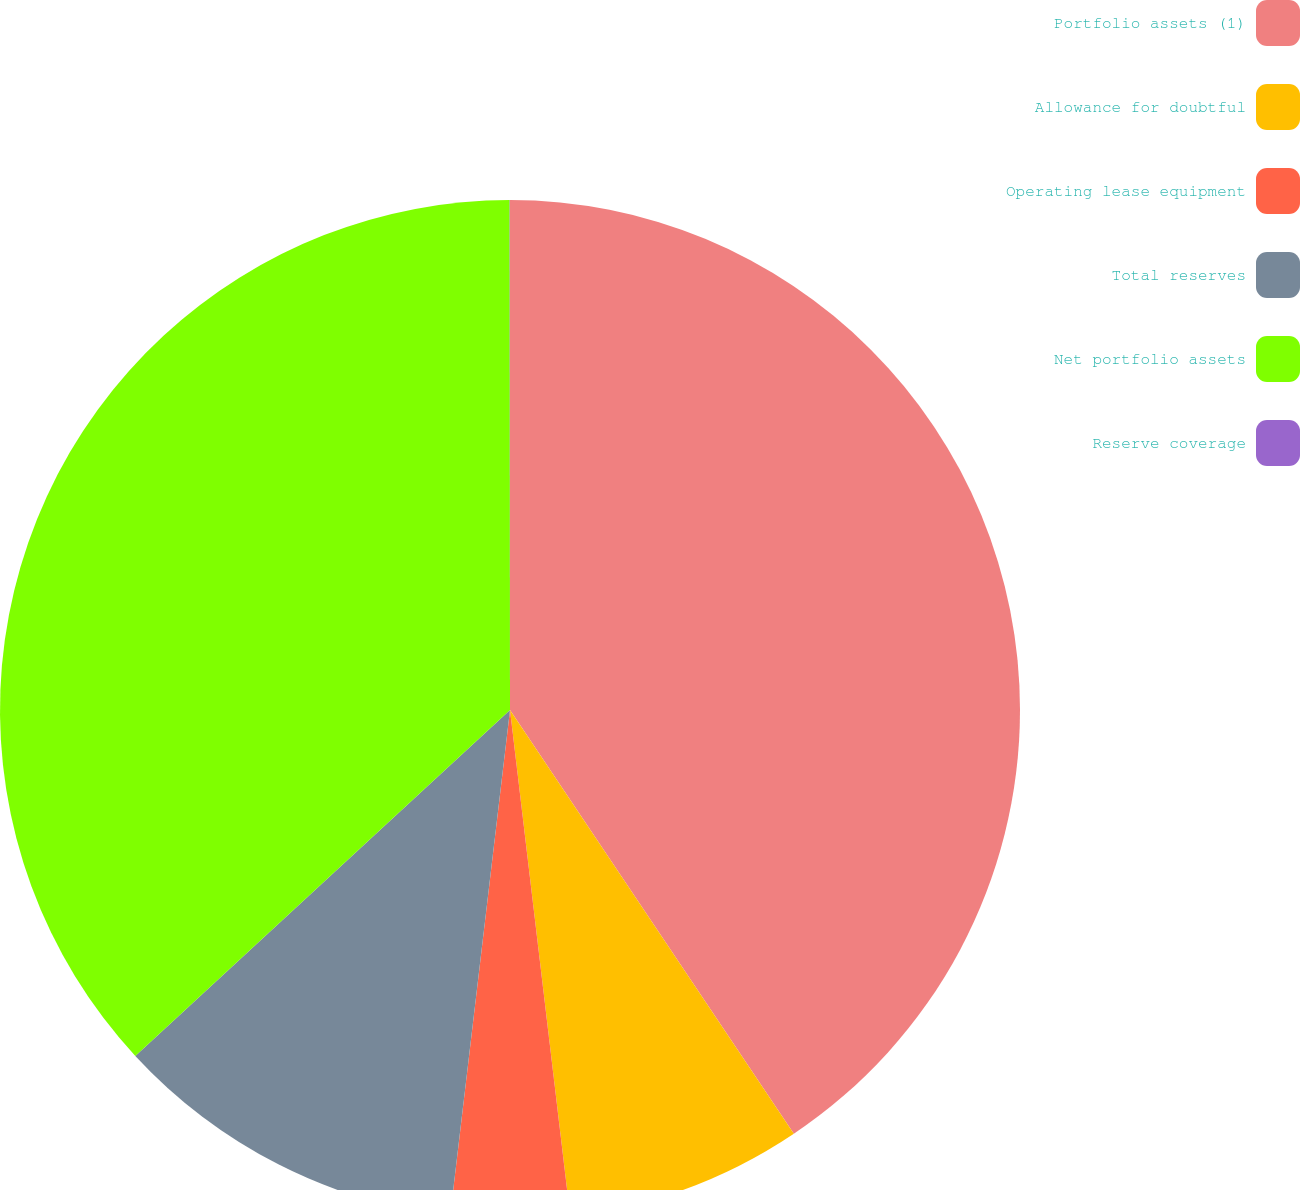<chart> <loc_0><loc_0><loc_500><loc_500><pie_chart><fcel>Portfolio assets (1)<fcel>Allowance for doubtful<fcel>Operating lease equipment<fcel>Total reserves<fcel>Net portfolio assets<fcel>Reserve coverage<nl><fcel>40.61%<fcel>7.51%<fcel>3.76%<fcel>11.26%<fcel>36.86%<fcel>0.01%<nl></chart> 